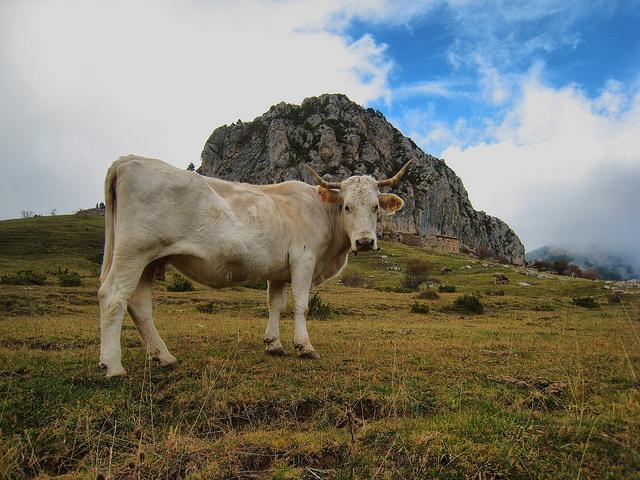How many cows are there?
Give a very brief answer. 1. How many horns are in this picture?
Give a very brief answer. 2. How many adult cows are in the photo?
Give a very brief answer. 1. How many cows are in the picture?
Give a very brief answer. 1. 